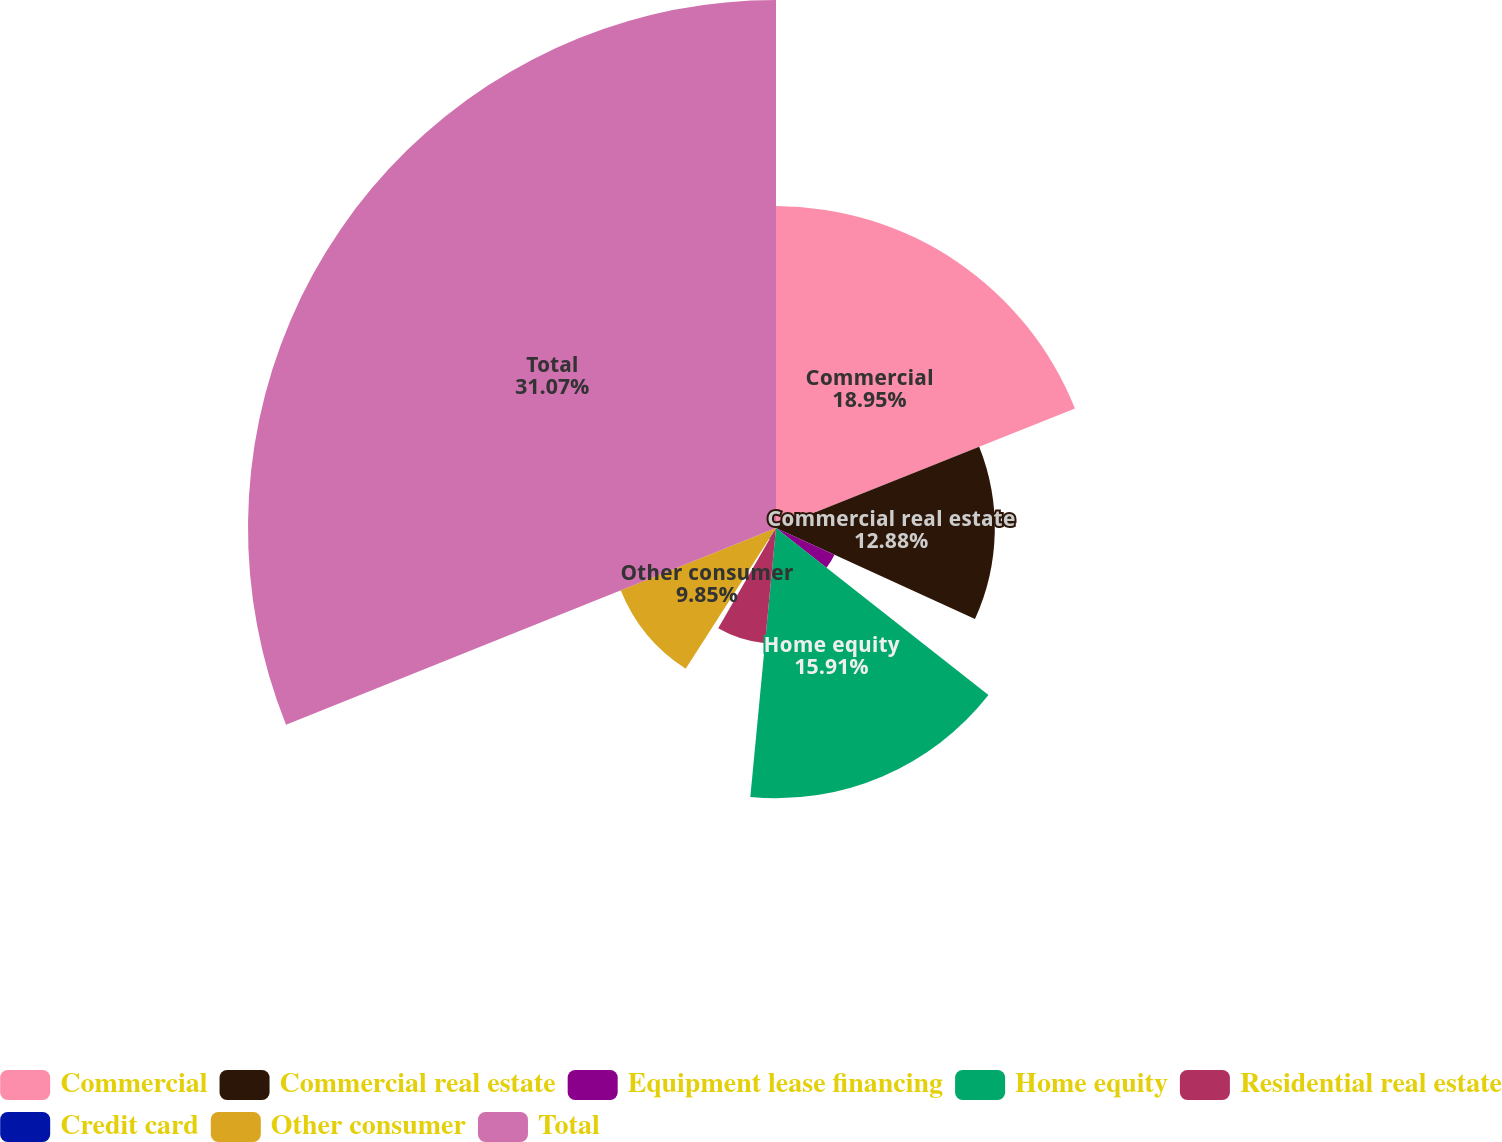Convert chart. <chart><loc_0><loc_0><loc_500><loc_500><pie_chart><fcel>Commercial<fcel>Commercial real estate<fcel>Equipment lease financing<fcel>Home equity<fcel>Residential real estate<fcel>Credit card<fcel>Other consumer<fcel>Total<nl><fcel>18.95%<fcel>12.88%<fcel>3.78%<fcel>15.91%<fcel>6.81%<fcel>0.75%<fcel>9.85%<fcel>31.08%<nl></chart> 